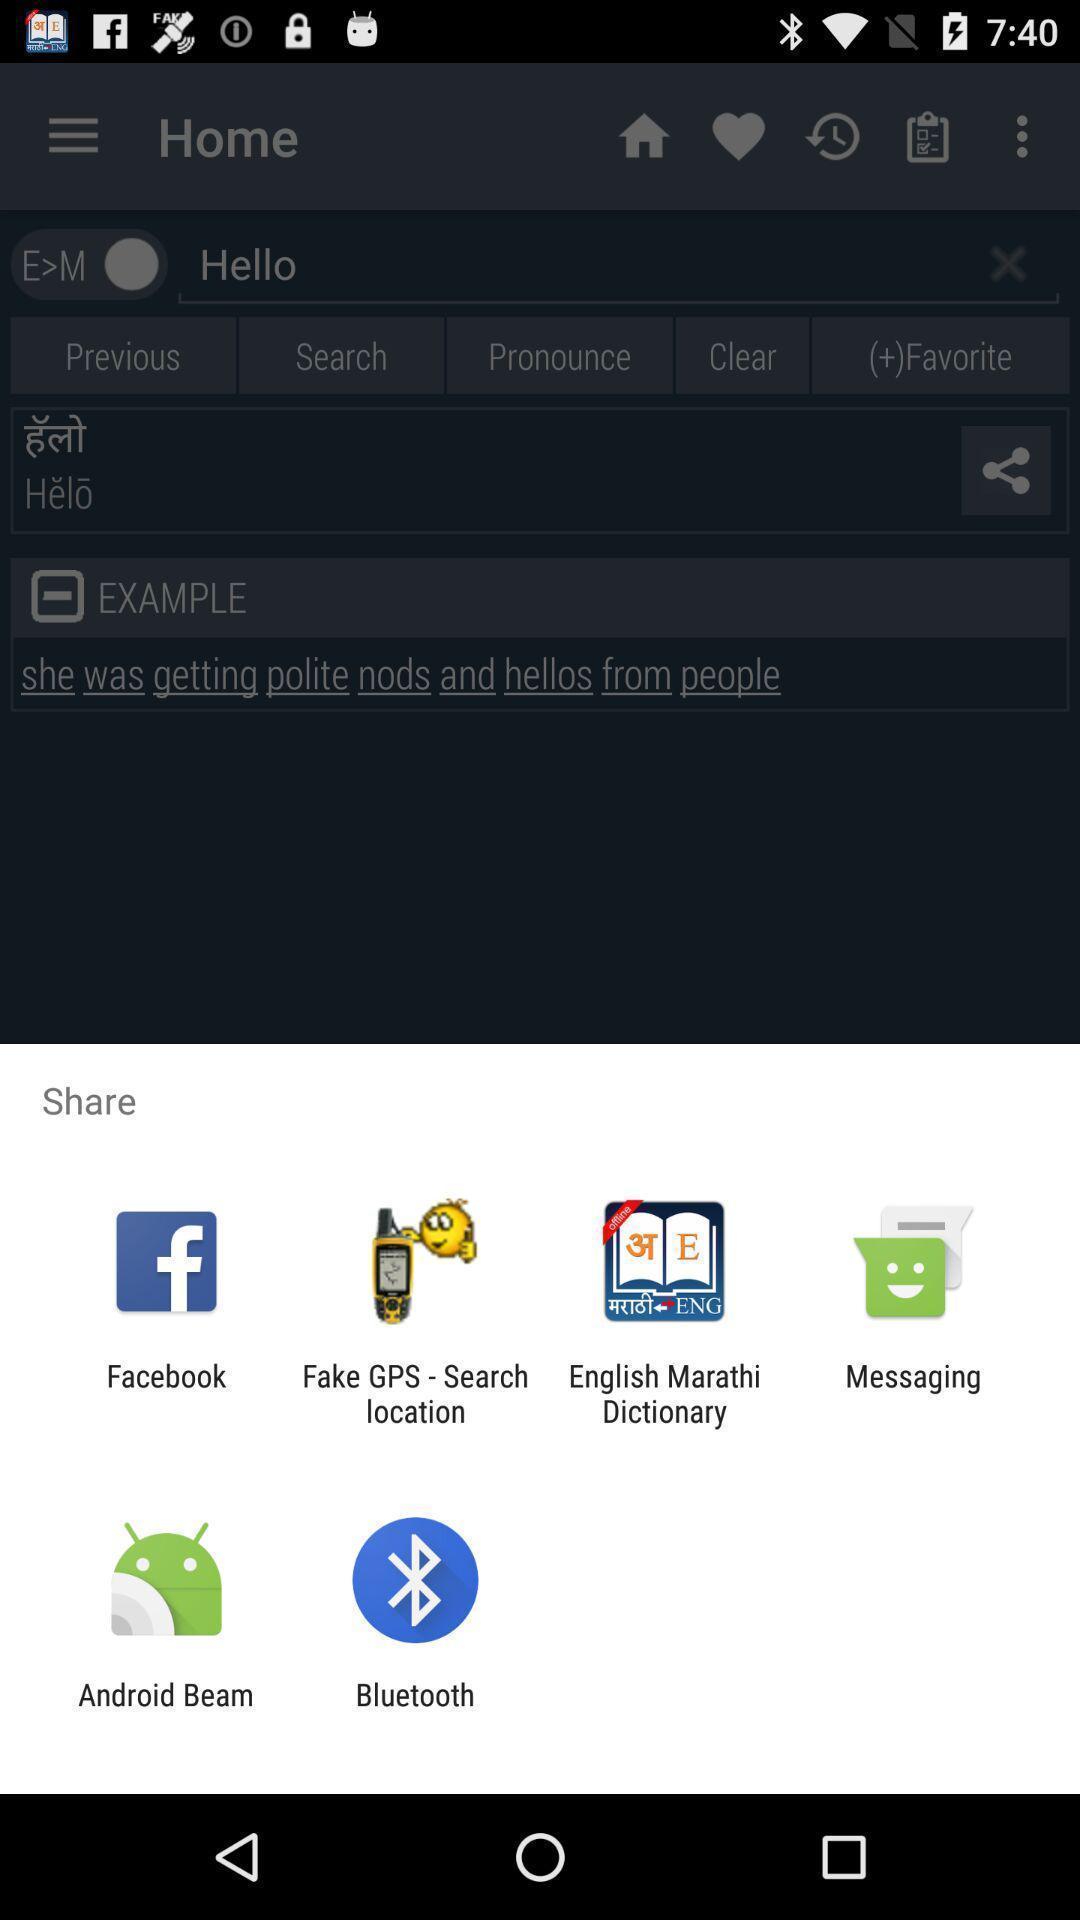Describe the visual elements of this screenshot. Screen displaying share options. 